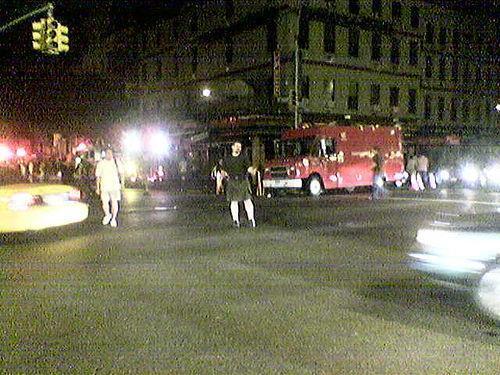How many cars are there?
Give a very brief answer. 2. How many chairs in this image have visible legs?
Give a very brief answer. 0. 